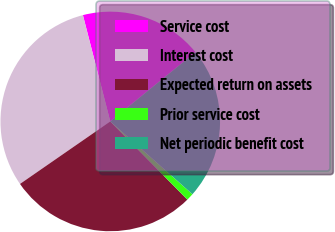Convert chart. <chart><loc_0><loc_0><loc_500><loc_500><pie_chart><fcel>Service cost<fcel>Interest cost<fcel>Expected return on assets<fcel>Prior service cost<fcel>Net periodic benefit cost<nl><fcel>18.14%<fcel>30.63%<fcel>27.75%<fcel>1.07%<fcel>22.41%<nl></chart> 